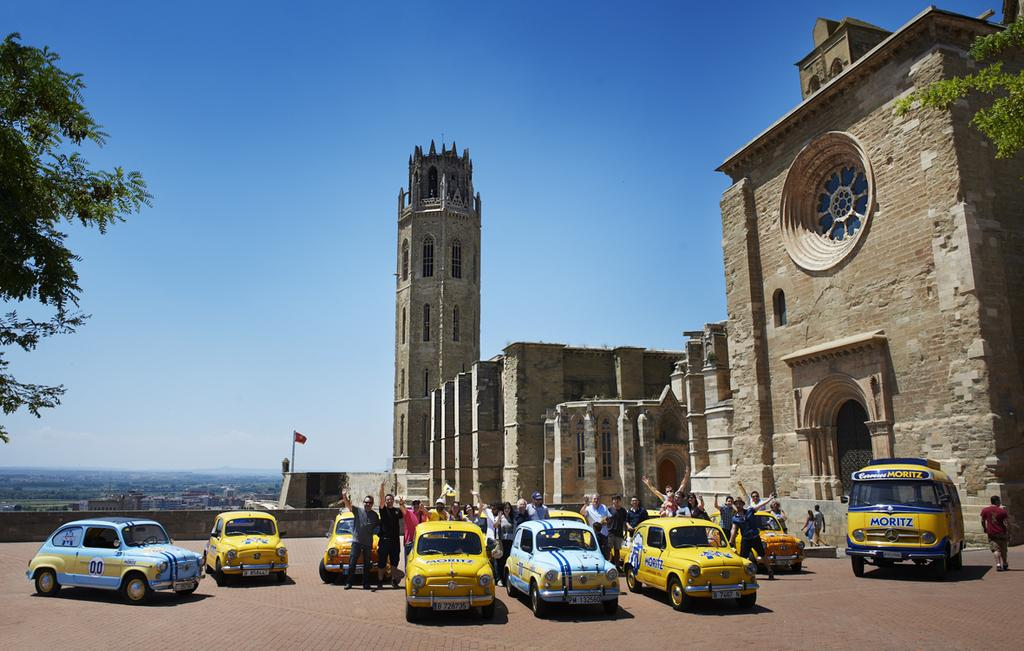<image>
Relay a brief, clear account of the picture shown. A crowd of people are gathered around a cluster of sports cars that say Moritz and a cathedral is in the background. 